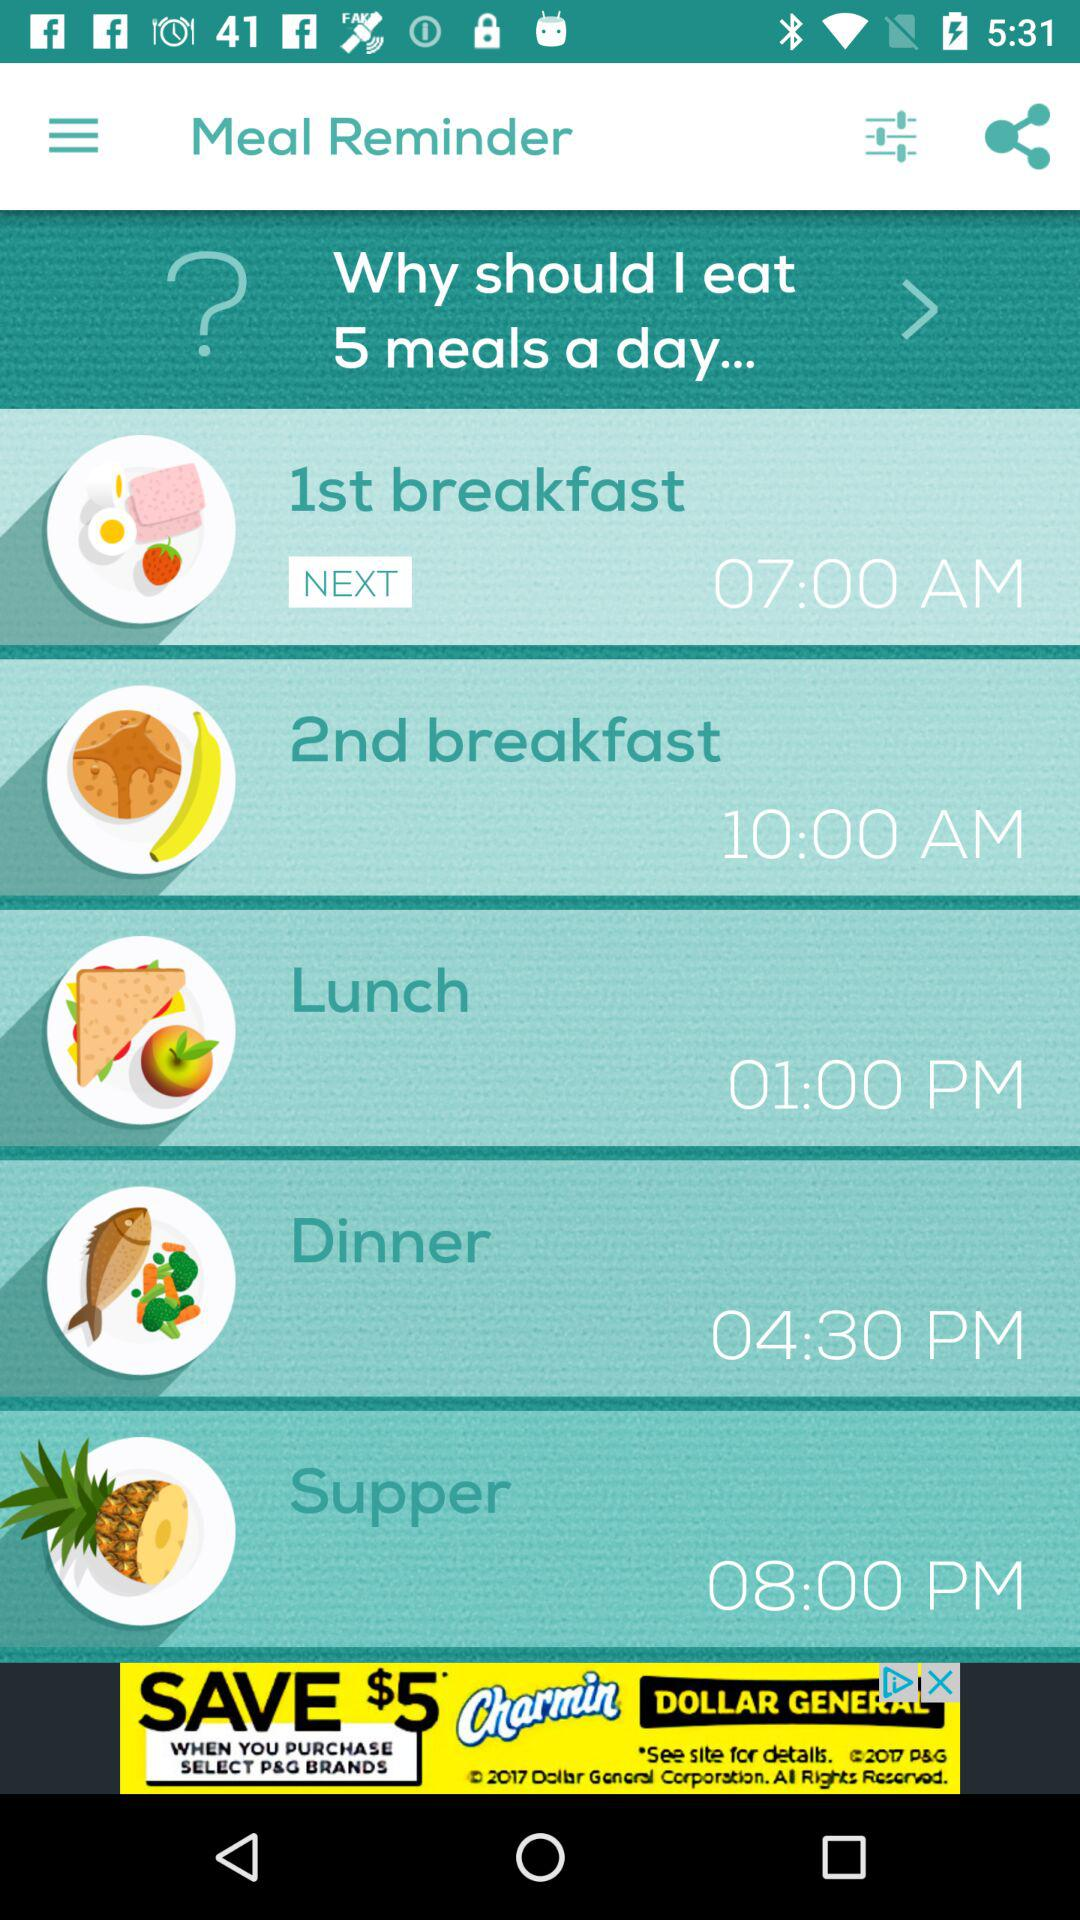How many meals are scheduled for the day? The image displays a meal reminder application with five scheduled meals for the day—1st breakfast at 7:00 AM, 2nd breakfast at 10:00 AM, lunch at 1:00 PM, dinner at 4:30 PM, and supper at 8:00 PM. 